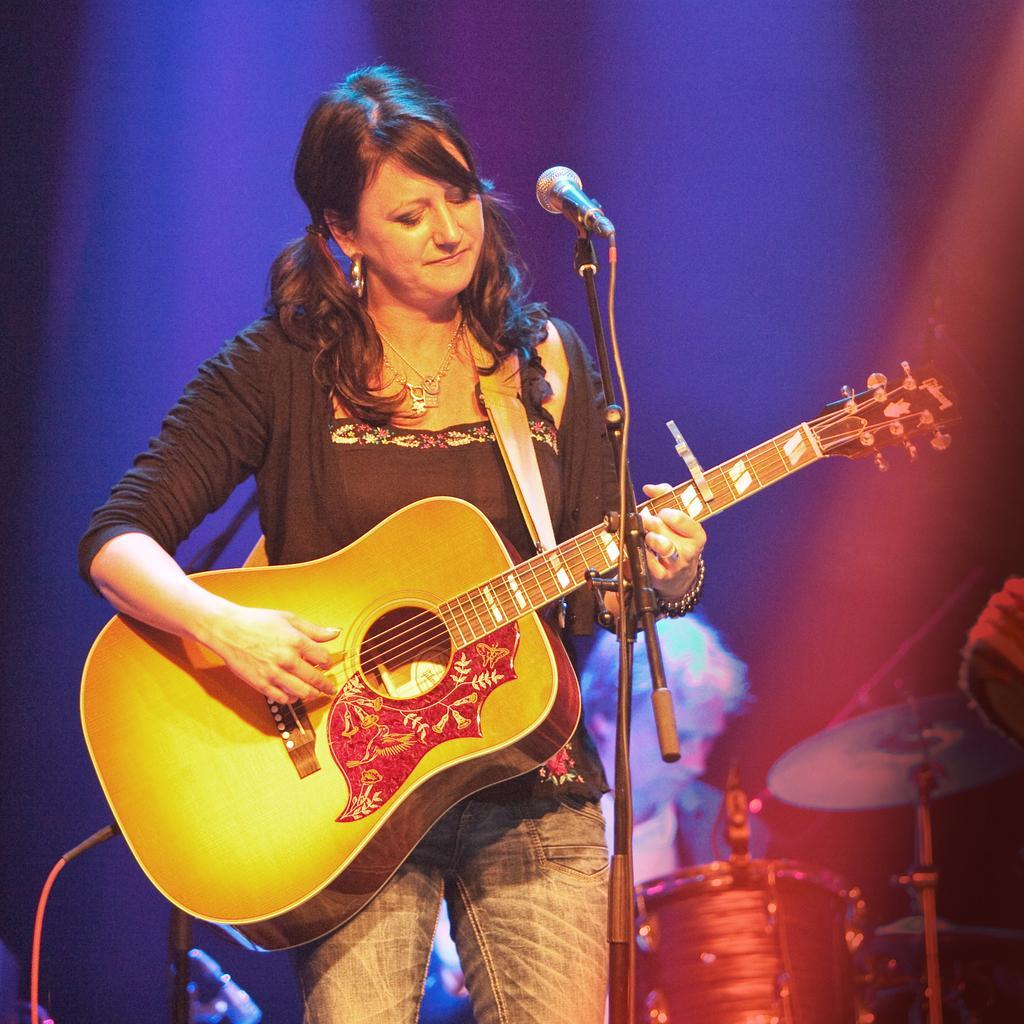Please provide a concise description of this image. This picture shows a woman standing and playing a guitar and we see a microphone and a man seated on the back and playing drums. 